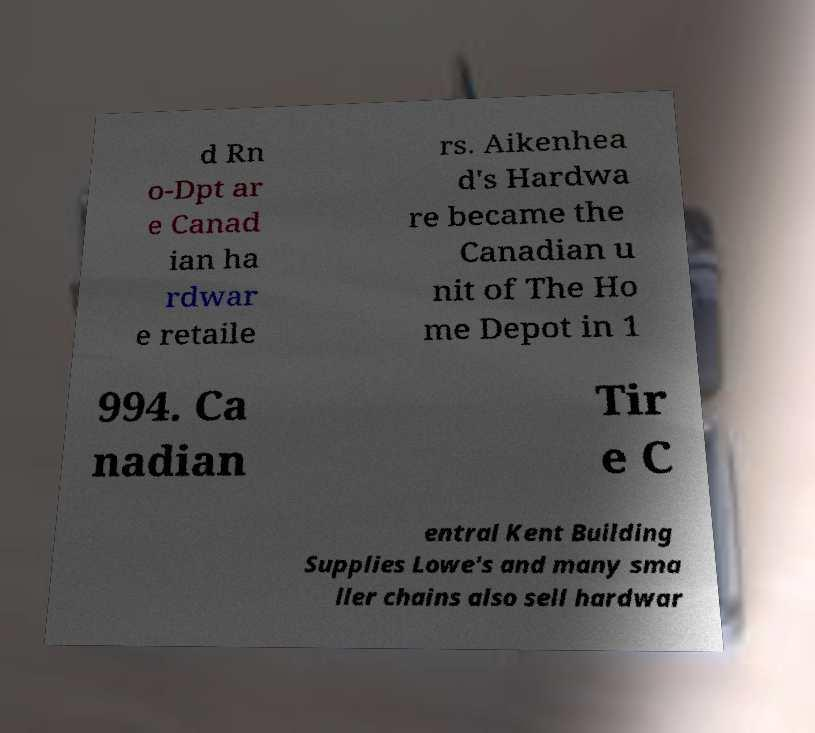Can you accurately transcribe the text from the provided image for me? d Rn o-Dpt ar e Canad ian ha rdwar e retaile rs. Aikenhea d's Hardwa re became the Canadian u nit of The Ho me Depot in 1 994. Ca nadian Tir e C entral Kent Building Supplies Lowe's and many sma ller chains also sell hardwar 